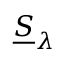Convert formula to latex. <formula><loc_0><loc_0><loc_500><loc_500>{ \underline { S } } _ { \lambda }</formula> 